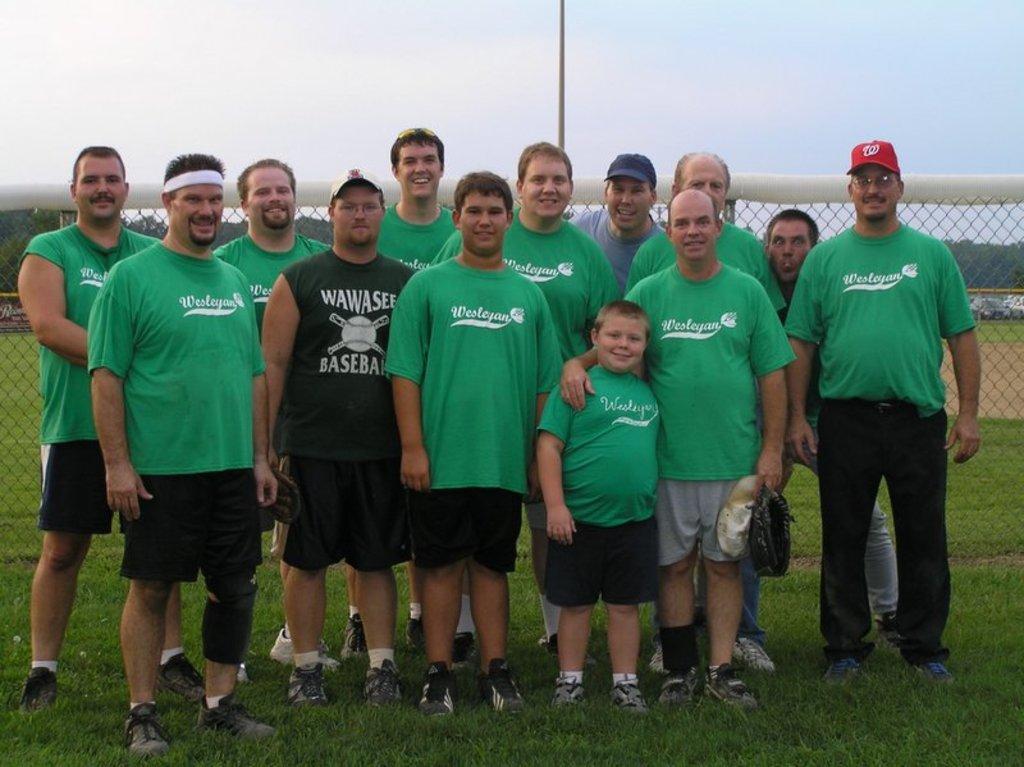Could you give a brief overview of what you see in this image? This picture might be taken inside a playground. In this picture, in the middle, we can see group of people standing on the grass. In the background, we can also see net fence, pole, trees, cars. On the top, we can see a sky, at the bottom there is a grass. 